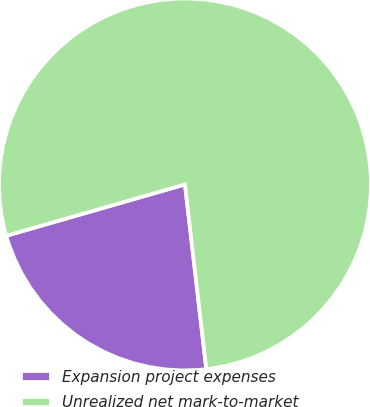Convert chart to OTSL. <chart><loc_0><loc_0><loc_500><loc_500><pie_chart><fcel>Expansion project expenses<fcel>Unrealized net mark-to-market<nl><fcel>22.38%<fcel>77.62%<nl></chart> 